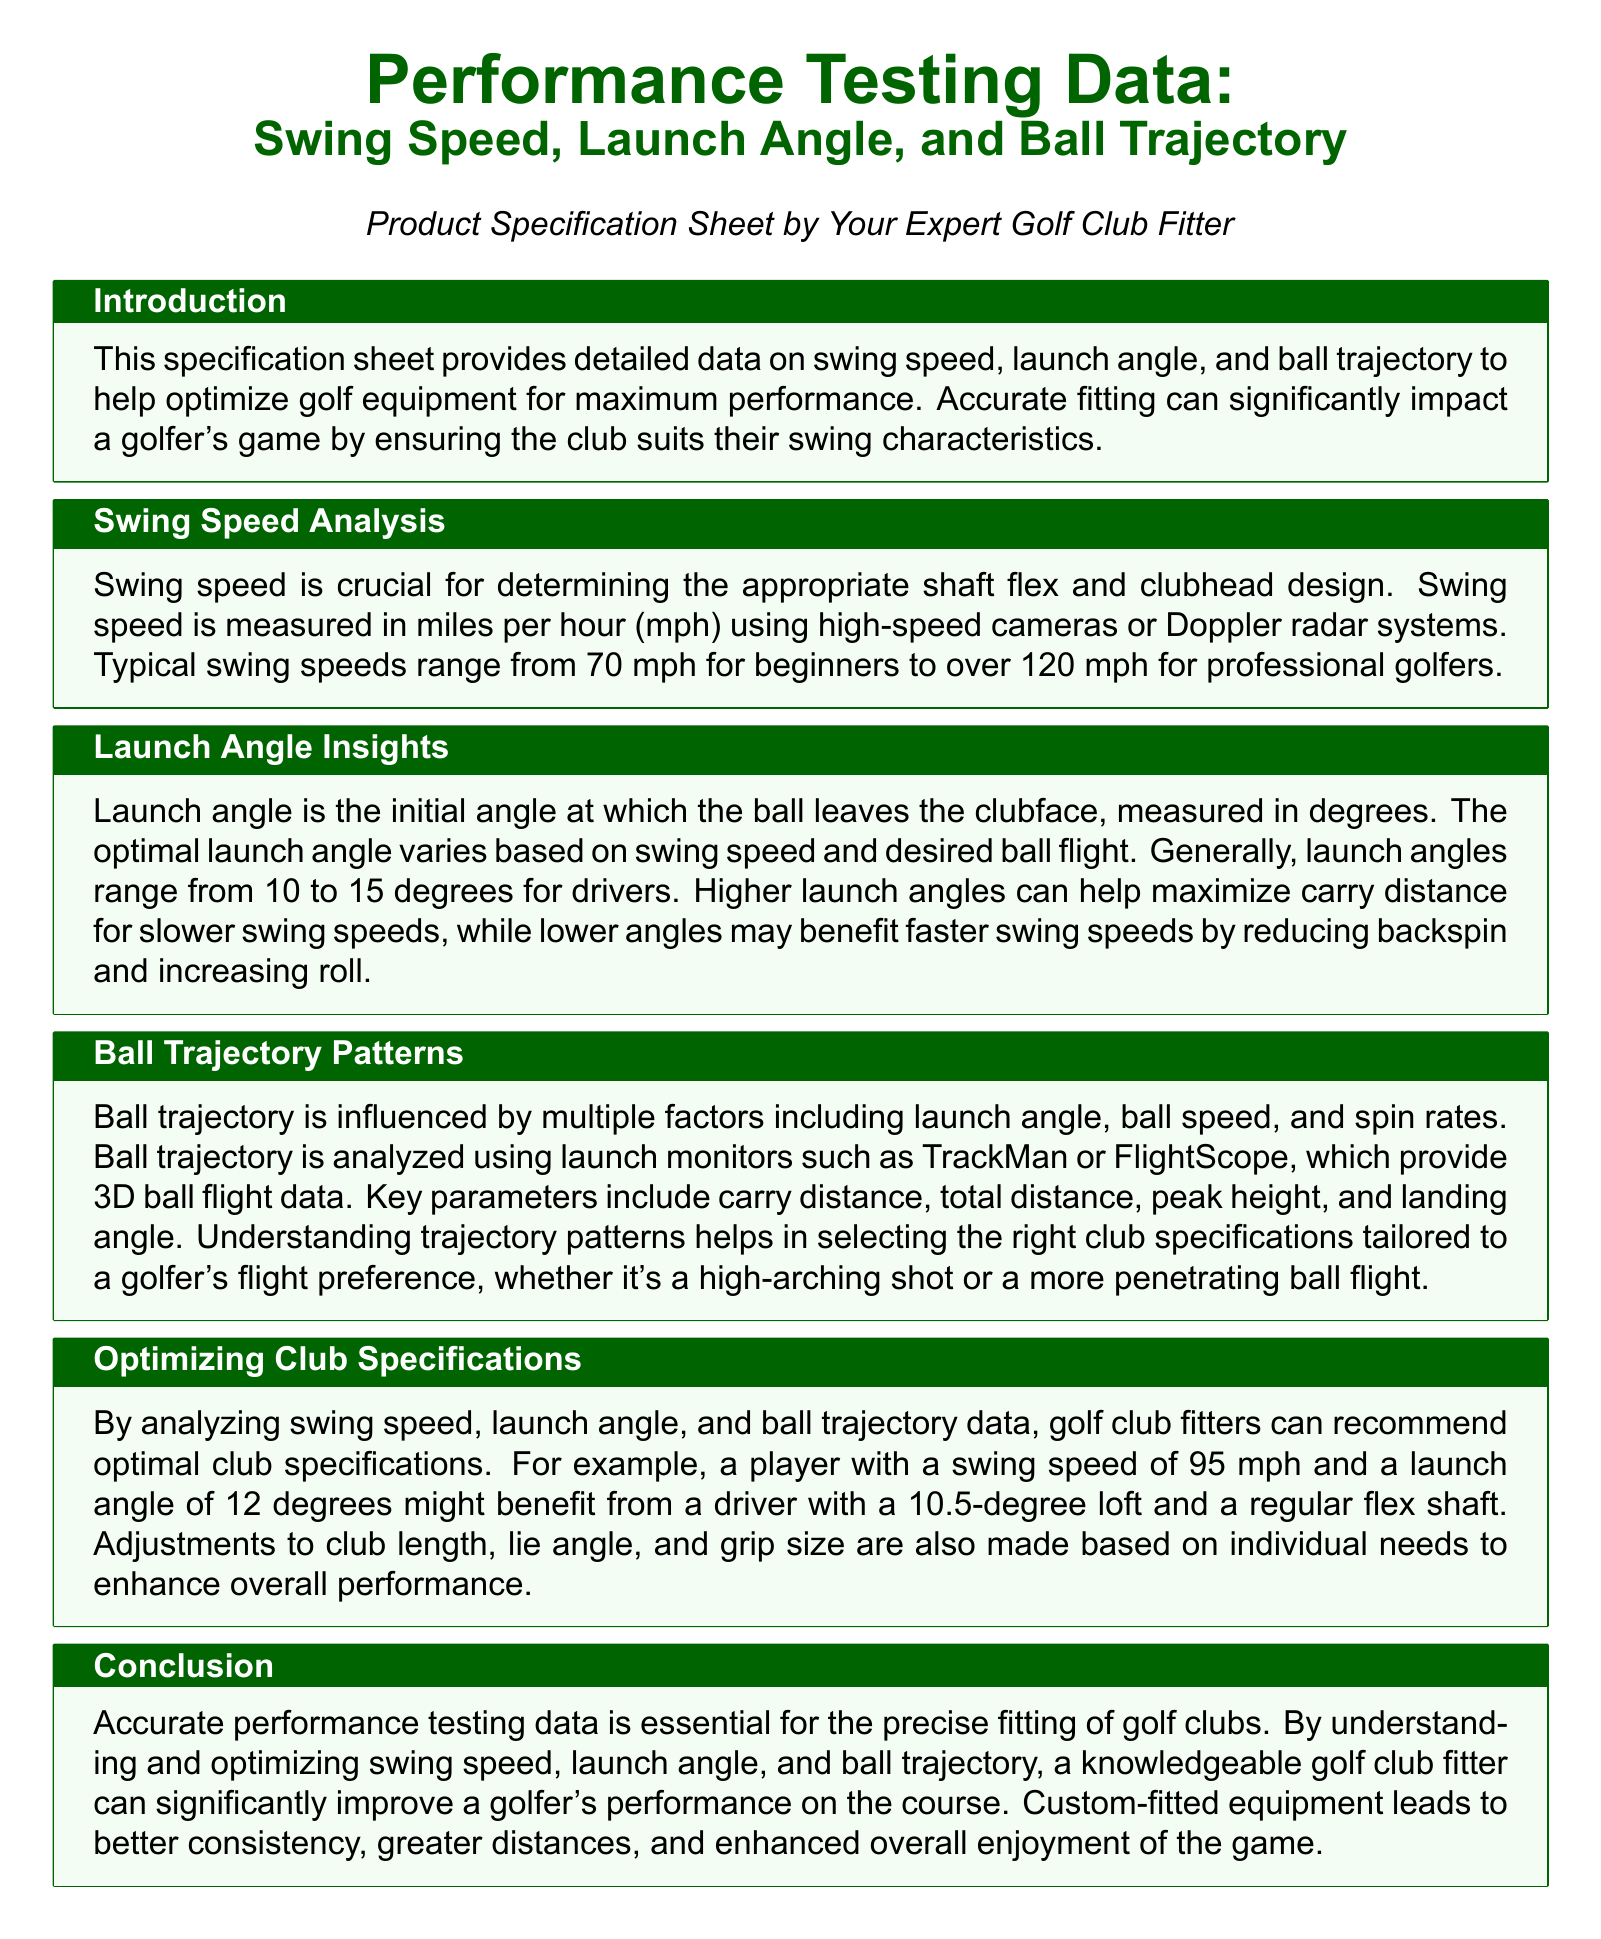What is the typical range of swing speeds for golfers? The document states that typical swing speeds range from 70 mph for beginners to over 120 mph for professional golfers.
Answer: 70 mph to over 120 mph What is the optimal launch angle range for drivers? The document indicates that generally, launch angles range from 10 to 15 degrees for drivers.
Answer: 10 to 15 degrees What tool is mentioned for analyzing ball trajectory? The document refers to launch monitors like TrackMan or FlightScope for analyzing ball trajectory.
Answer: TrackMan or FlightScope What swing speed and launch angle are provided as an example for club specification optimization? The document provides the example of a player with a swing speed of 95 mph and a launch angle of 12 degrees for club specification optimization.
Answer: 95 mph and 12 degrees What is essential for precise fitting of golf clubs? The document states that accurate performance testing data is essential for the precise fitting of golf clubs.
Answer: Accurate performance testing data Why might a golfer benefit from a higher launch angle? The document explains that higher launch angles can help maximize carry distance for slower swing speeds.
Answer: Maximize carry distance What is one of the key parameters used in ball trajectory analysis? The document lists carry distance, total distance, peak height, and landing angle as key parameters; one of them is carry distance.
Answer: Carry distance Who is the intended audience for the specification sheet? The document specifies that the sheet is for golfers and mentions it is provided by an expert golf club fitter.
Answer: Golfer 